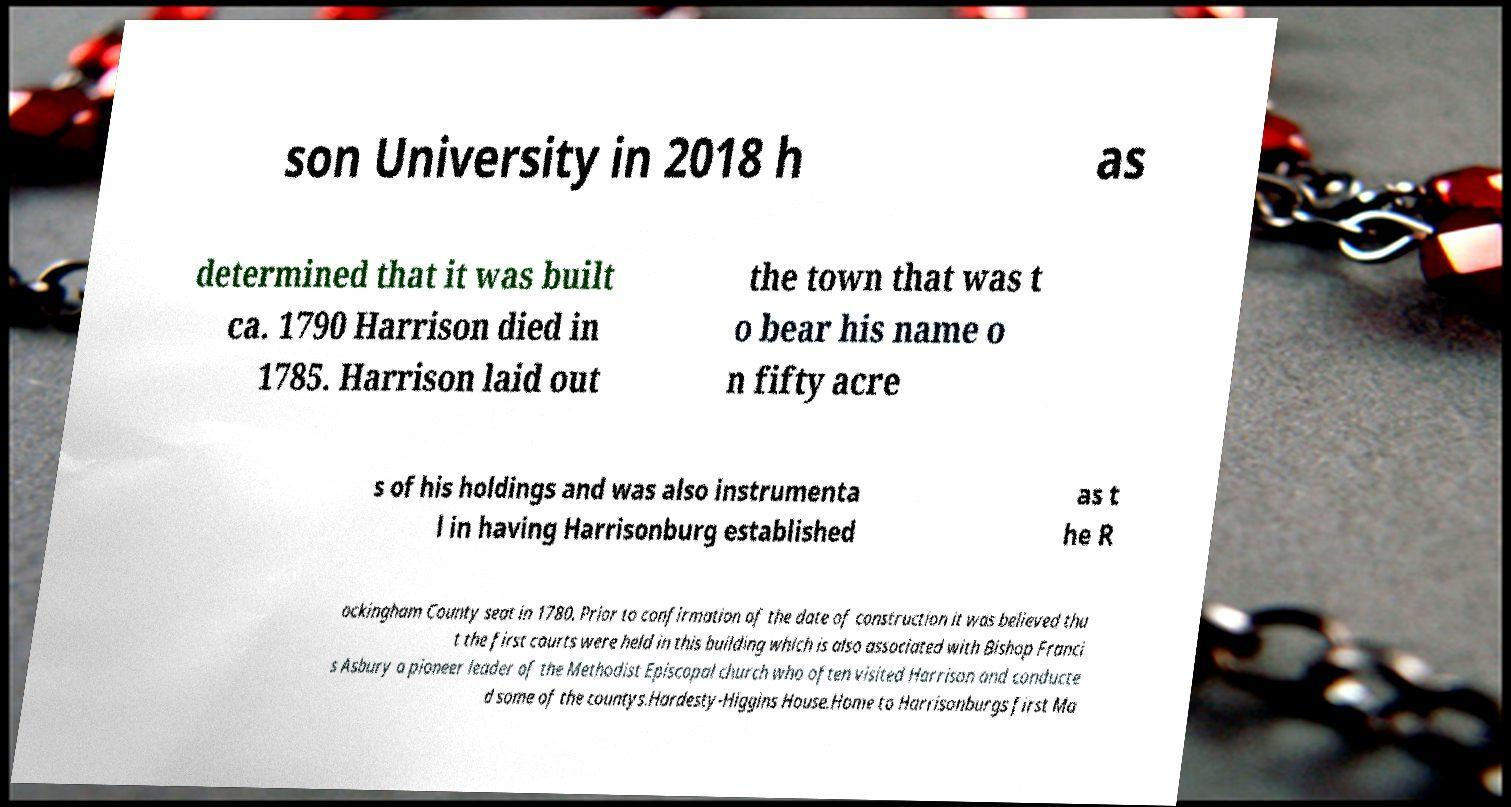Can you accurately transcribe the text from the provided image for me? son University in 2018 h as determined that it was built ca. 1790 Harrison died in 1785. Harrison laid out the town that was t o bear his name o n fifty acre s of his holdings and was also instrumenta l in having Harrisonburg established as t he R ockingham County seat in 1780. Prior to confirmation of the date of construction it was believed tha t the first courts were held in this building which is also associated with Bishop Franci s Asbury a pioneer leader of the Methodist Episcopal church who often visited Harrison and conducte d some of the countys.Hardesty-Higgins House.Home to Harrisonburgs first Ma 